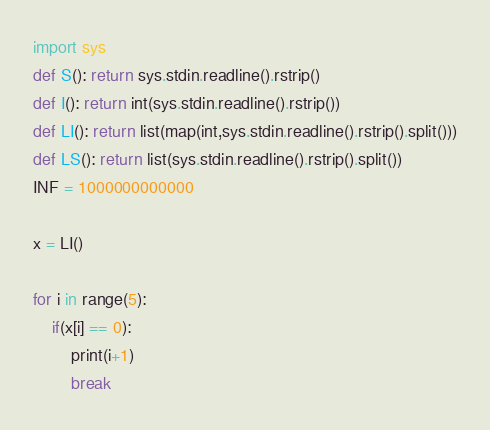Convert code to text. <code><loc_0><loc_0><loc_500><loc_500><_Python_>import sys
def S(): return sys.stdin.readline().rstrip()
def I(): return int(sys.stdin.readline().rstrip())
def LI(): return list(map(int,sys.stdin.readline().rstrip().split()))
def LS(): return list(sys.stdin.readline().rstrip().split())
INF = 1000000000000

x = LI()

for i in range(5):
    if(x[i] == 0):
        print(i+1)
        break</code> 